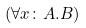Convert formula to latex. <formula><loc_0><loc_0><loc_500><loc_500>( \forall x \colon A . B )</formula> 